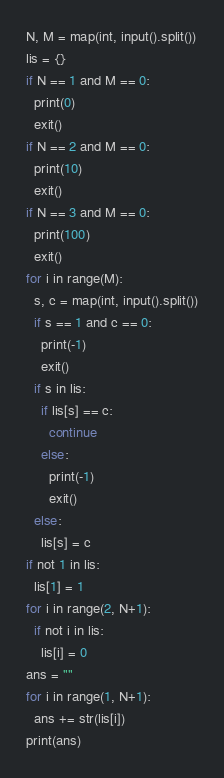Convert code to text. <code><loc_0><loc_0><loc_500><loc_500><_Python_>N, M = map(int, input().split())
lis = {}
if N == 1 and M == 0:
  print(0)
  exit()
if N == 2 and M == 0:
  print(10)
  exit()
if N == 3 and M == 0:
  print(100)
  exit()
for i in range(M):
  s, c = map(int, input().split())
  if s == 1 and c == 0:
    print(-1)
    exit()
  if s in lis:
    if lis[s] == c:
      continue
    else:
      print(-1)
      exit()
  else:
    lis[s] = c
if not 1 in lis:
  lis[1] = 1
for i in range(2, N+1):
  if not i in lis:
    lis[i] = 0
ans = ""
for i in range(1, N+1):
  ans += str(lis[i])
print(ans)</code> 